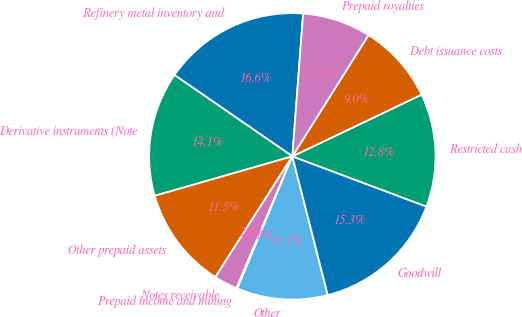Convert chart. <chart><loc_0><loc_0><loc_500><loc_500><pie_chart><fcel>Refinery metal inventory and<fcel>Derivative instruments (Note<fcel>Other prepaid assets<fcel>Notes receivable<fcel>Prepaid income and mining<fcel>Other<fcel>Goodwill<fcel>Restricted cash<fcel>Debt issuance costs<fcel>Prepaid royalties<nl><fcel>16.59%<fcel>14.06%<fcel>11.52%<fcel>2.65%<fcel>0.11%<fcel>10.25%<fcel>15.32%<fcel>12.79%<fcel>8.99%<fcel>7.72%<nl></chart> 